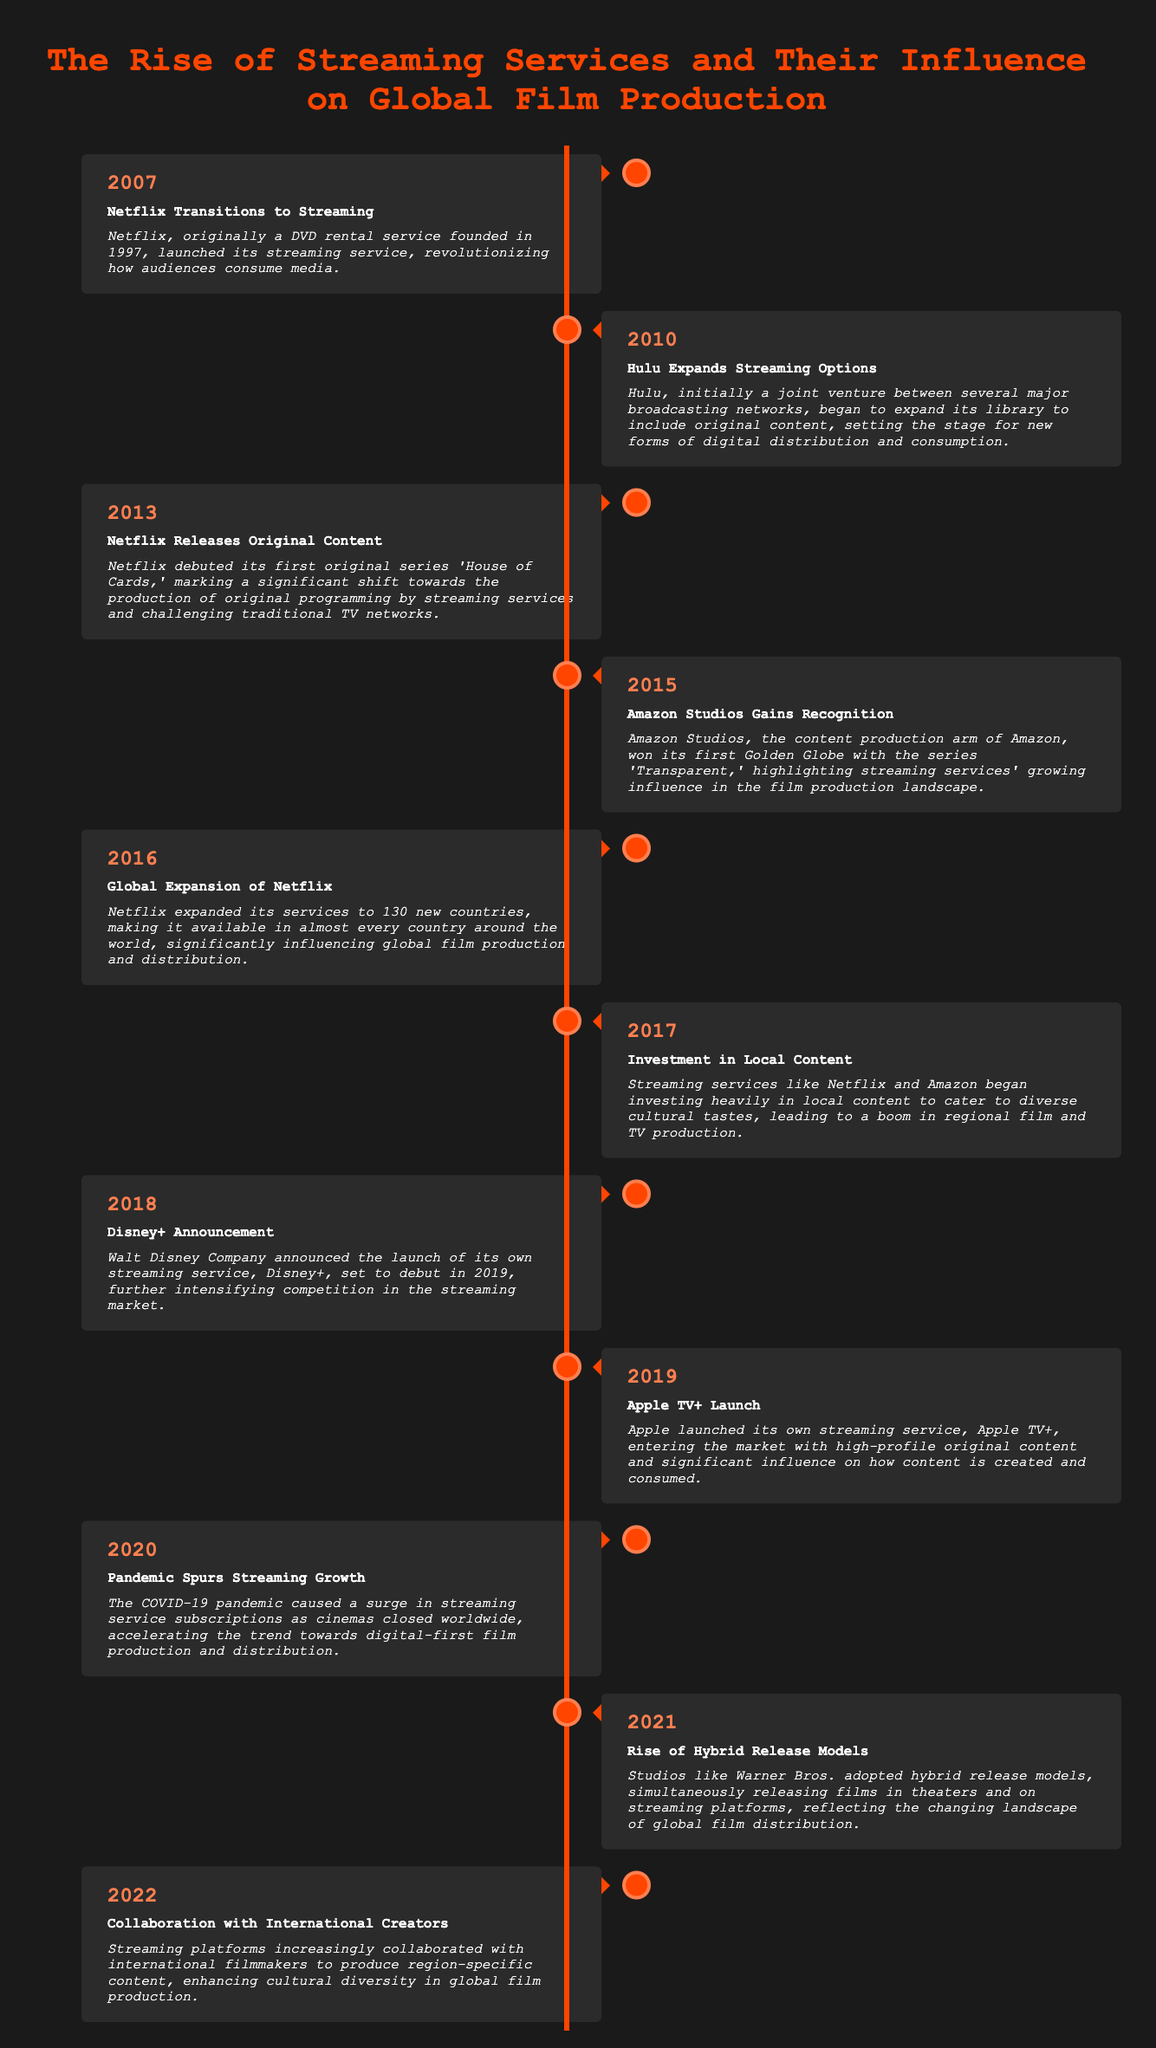What year did Netflix transition to streaming? The document states that Netflix transitioned to streaming in 2007.
Answer: 2007 What original series did Netflix debut in 2013? According to the document, Netflix debuted the original series 'House of Cards' in 2013.
Answer: House of Cards Which streaming service won its first Golden Globe in 2015? The document notes that Amazon Studios won its first Golden Globe in 2015.
Answer: Amazon Studios What significant event occurred in 2020 that affected streaming services? The document indicates that the COVID-19 pandemic caused a surge in streaming service subscriptions in 2020.
Answer: Pandemic In what year did Disney+ announce its launch? The document mentions that Disney+ announced its launch in 2018.
Answer: 2018 What shift did streaming services make in 2017? The document explains that in 2017, streaming services began investing heavily in local content.
Answer: Local content Which streaming service launched in 2019? The document states that Apple launched its own streaming service, Apple TV+, in 2019.
Answer: Apple TV+ What has been a trend regarding international collaborations since 2022? The document indicates that streaming platforms have increasingly collaborated with international filmmakers since 2022.
Answer: Collaborations What type of release model did Warner Bros. adopt in 2021? The document specifies that Warner Bros. adopted hybrid release models in 2021.
Answer: Hybrid release models 